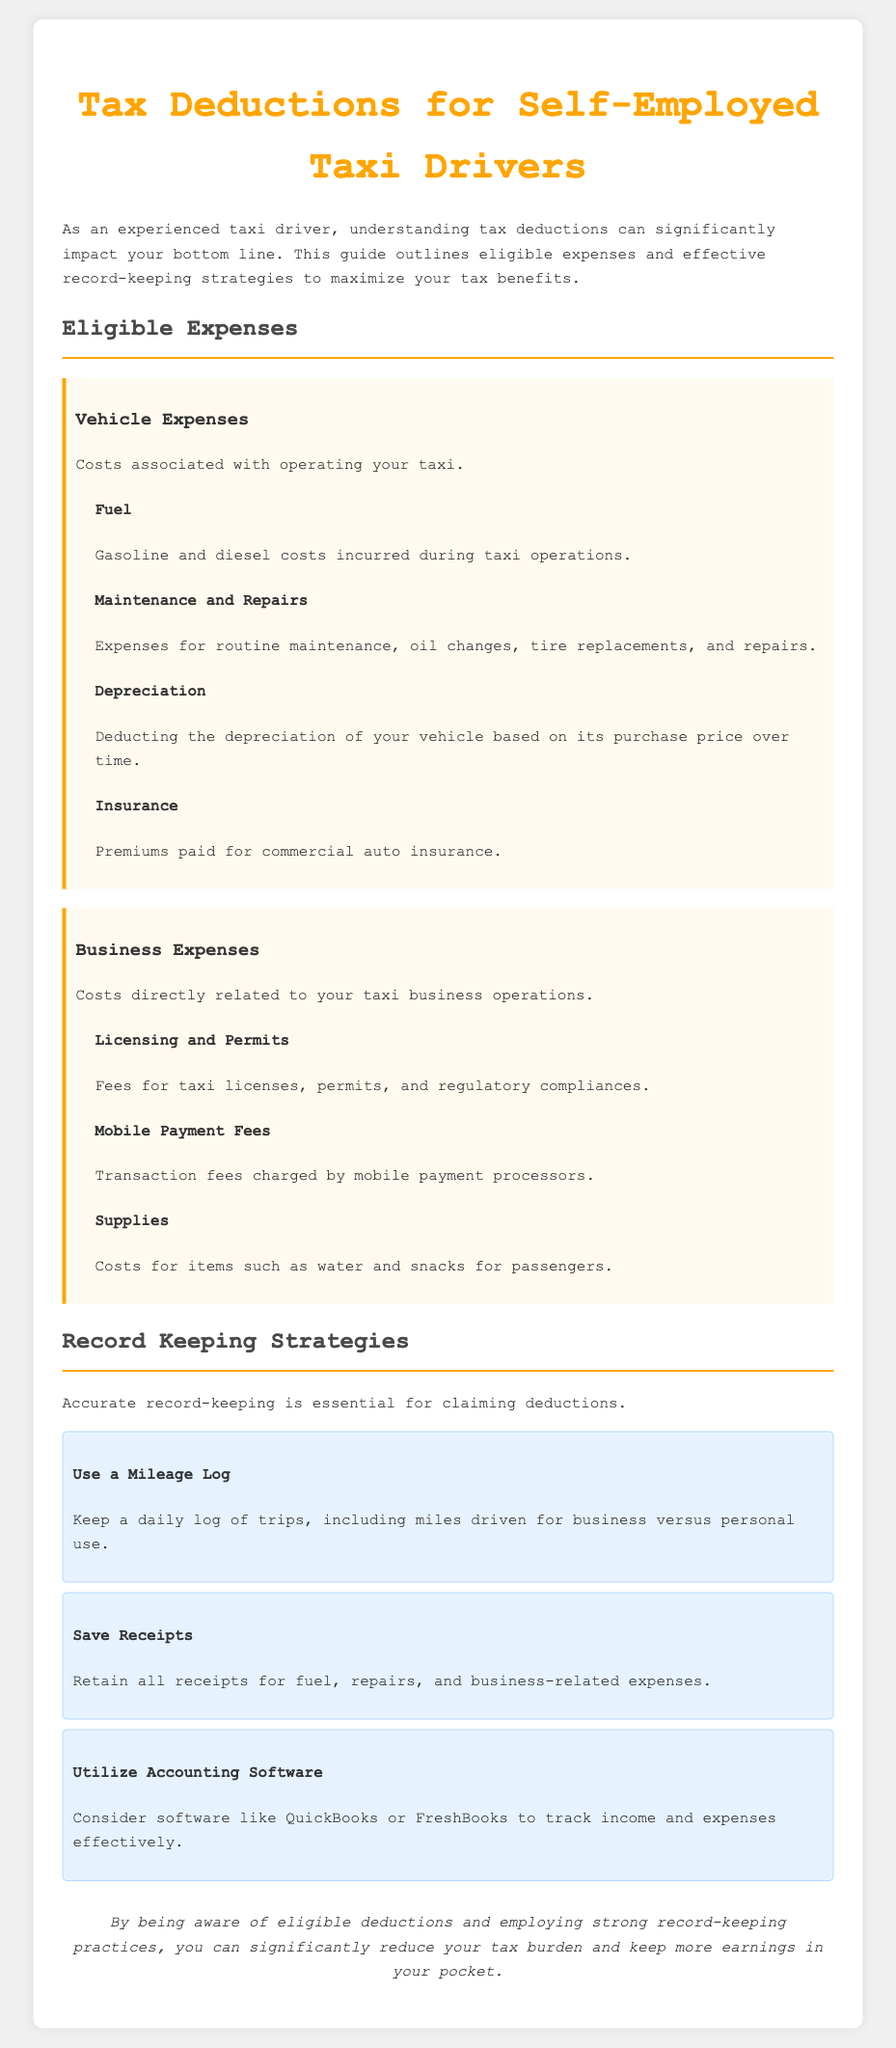What are the vehicle expenses outlined in the document? The document specifies various vehicle expenses like fuel, maintenance and repairs, depreciation, and insurance as eligible for tax deductions.
Answer: Fuel, Maintenance and Repairs, Depreciation, Insurance What type of fees are included under business expenses? The document mentions licensing and permits, mobile payment fees, and supplies as costs directly related to taxi business operations.
Answer: Licensing and Permits, Mobile Payment Fees, Supplies What strategy is suggested for tracking business mileage? The note recommends keeping a daily log of trips for business and personal use to accurately track mileage.
Answer: Mileage Log Which accounting software is recommended in the notes? The document suggests using software like QuickBooks or FreshBooks for effective tracking of income and expenses.
Answer: QuickBooks, FreshBooks How should receipts be kept according to the document? The guide advises retaining all receipts related to fuel, repairs, and other business-related expenses for record-keeping purposes.
Answer: Save Receipts What impact can eligible deductions and record-keeping practices have on earnings? The conclusion of the document states that being aware of deductions and maintaining good record-keeping can significantly reduce your tax burden and save more earnings.
Answer: Reduce tax burden What color is used for the headings in the document? The document uses orange as the color for the headings to stand out.
Answer: Orange 